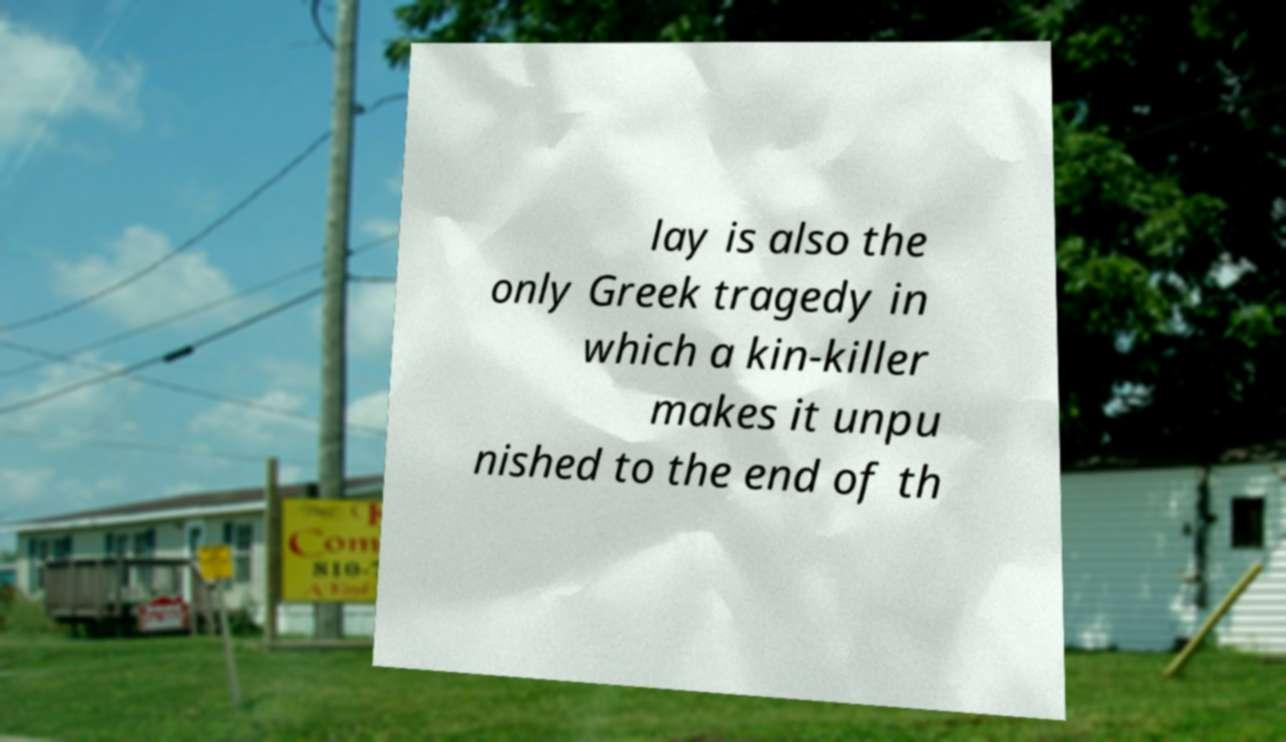Please identify and transcribe the text found in this image. lay is also the only Greek tragedy in which a kin-killer makes it unpu nished to the end of th 